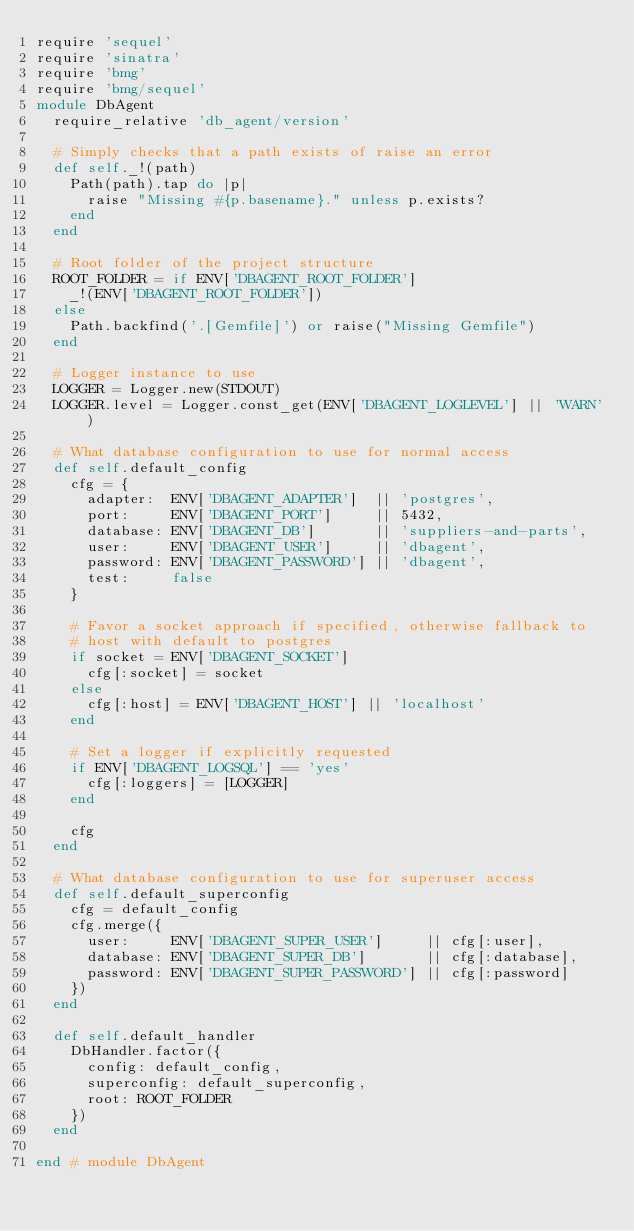<code> <loc_0><loc_0><loc_500><loc_500><_Ruby_>require 'sequel'
require 'sinatra'
require 'bmg'
require 'bmg/sequel'
module DbAgent
  require_relative 'db_agent/version'

  # Simply checks that a path exists of raise an error
  def self._!(path)
    Path(path).tap do |p|
      raise "Missing #{p.basename}." unless p.exists?
    end
  end

  # Root folder of the project structure
  ROOT_FOLDER = if ENV['DBAGENT_ROOT_FOLDER']
    _!(ENV['DBAGENT_ROOT_FOLDER'])
  else
    Path.backfind('.[Gemfile]') or raise("Missing Gemfile")
  end

  # Logger instance to use
  LOGGER = Logger.new(STDOUT)
  LOGGER.level = Logger.const_get(ENV['DBAGENT_LOGLEVEL'] || 'WARN')

  # What database configuration to use for normal access
  def self.default_config
    cfg = {
      adapter:  ENV['DBAGENT_ADAPTER']  || 'postgres',
      port:     ENV['DBAGENT_PORT']     || 5432,
      database: ENV['DBAGENT_DB']       || 'suppliers-and-parts',
      user:     ENV['DBAGENT_USER']     || 'dbagent',
      password: ENV['DBAGENT_PASSWORD'] || 'dbagent',
      test:     false
    }

    # Favor a socket approach if specified, otherwise fallback to
    # host with default to postgres
    if socket = ENV['DBAGENT_SOCKET']
      cfg[:socket] = socket
    else
      cfg[:host] = ENV['DBAGENT_HOST'] || 'localhost'
    end

    # Set a logger if explicitly requested
    if ENV['DBAGENT_LOGSQL'] == 'yes'
      cfg[:loggers] = [LOGGER]
    end

    cfg
  end

  # What database configuration to use for superuser access
  def self.default_superconfig
    cfg = default_config
    cfg.merge({
      user:     ENV['DBAGENT_SUPER_USER']     || cfg[:user],
      database: ENV['DBAGENT_SUPER_DB']       || cfg[:database],
      password: ENV['DBAGENT_SUPER_PASSWORD'] || cfg[:password]
    })
  end

  def self.default_handler
    DbHandler.factor({
      config: default_config,
      superconfig: default_superconfig,
      root: ROOT_FOLDER
    })
  end

end # module DbAgent</code> 